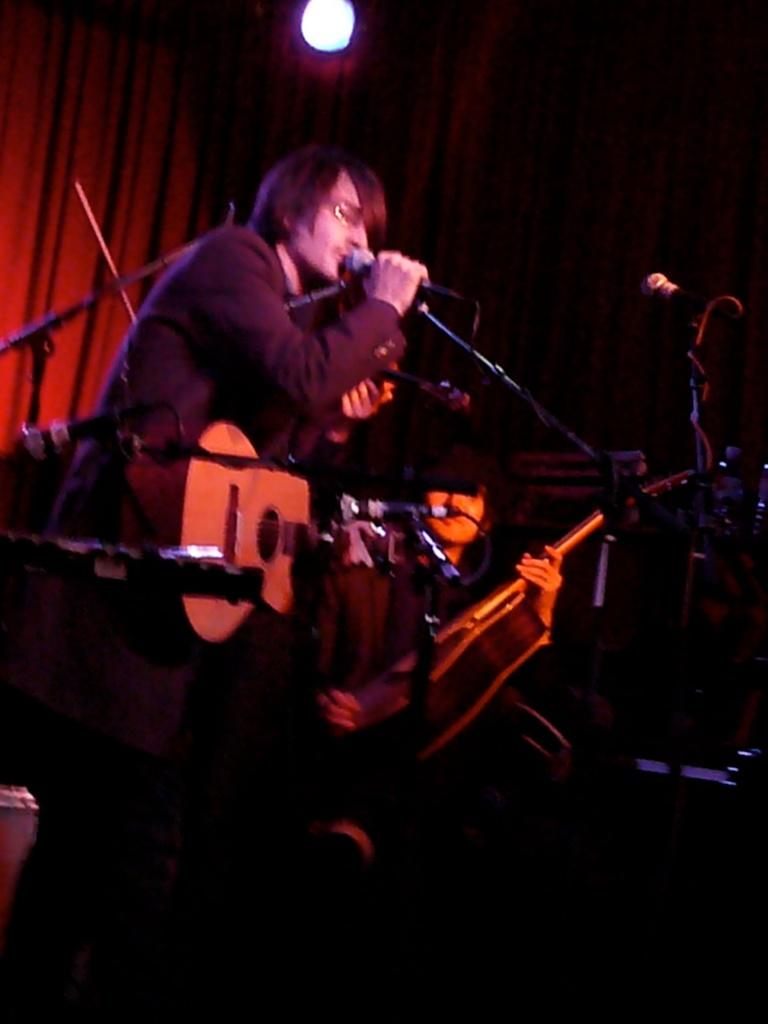What is the person in the image doing? The person is standing and singing in the image. What instrument is the person holding? The person is holding a guitar. Are there any other musicians in the image? Yes, there is another person holding a guitar in the image. What can be seen in the background of the image? There are curtains visible in the background. What is the source of light in the image? There is a light on top in the image. How many fish are visible in the person's pocket in the image? There are no fish or pockets visible in the image. 